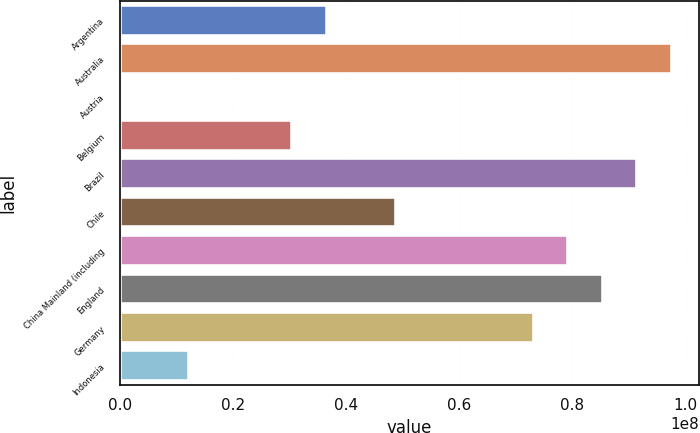Convert chart to OTSL. <chart><loc_0><loc_0><loc_500><loc_500><bar_chart><fcel>Argentina<fcel>Australia<fcel>Austria<fcel>Belgium<fcel>Brazil<fcel>Chile<fcel>China Mainland (including<fcel>England<fcel>Germany<fcel>Indonesia<nl><fcel>3.65965e+07<fcel>9.75851e+07<fcel>3300<fcel>3.04976e+07<fcel>9.14863e+07<fcel>4.87942e+07<fcel>7.92885e+07<fcel>8.53874e+07<fcel>7.31897e+07<fcel>1.2201e+07<nl></chart> 